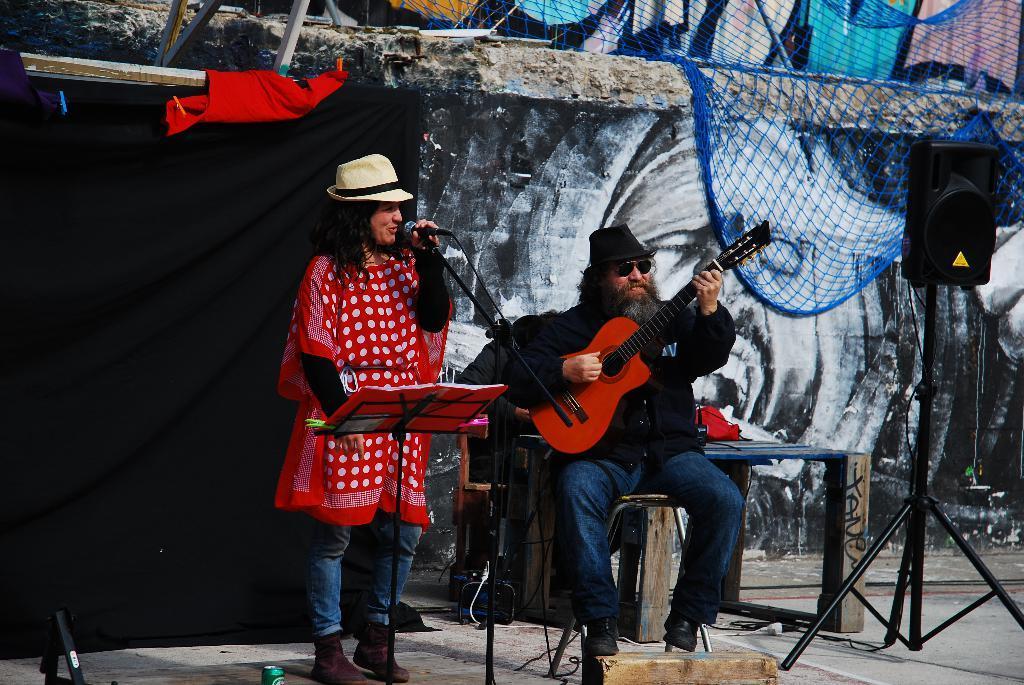In one or two sentences, can you explain what this image depicts? In this image I can see a person standing and holding a microphone and another person sitting and holding a guitar in his hands. I can see a speaker, the net which is blue in color, the black colored curtain and the wall with some painting on it. 